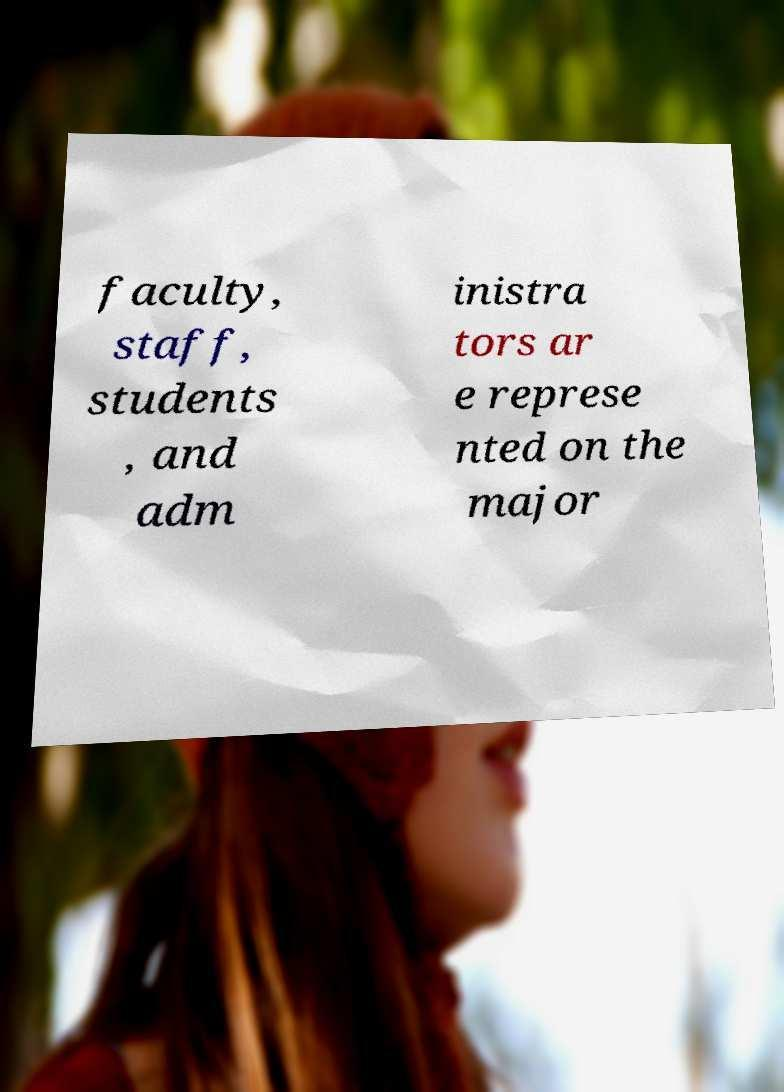Could you extract and type out the text from this image? faculty, staff, students , and adm inistra tors ar e represe nted on the major 